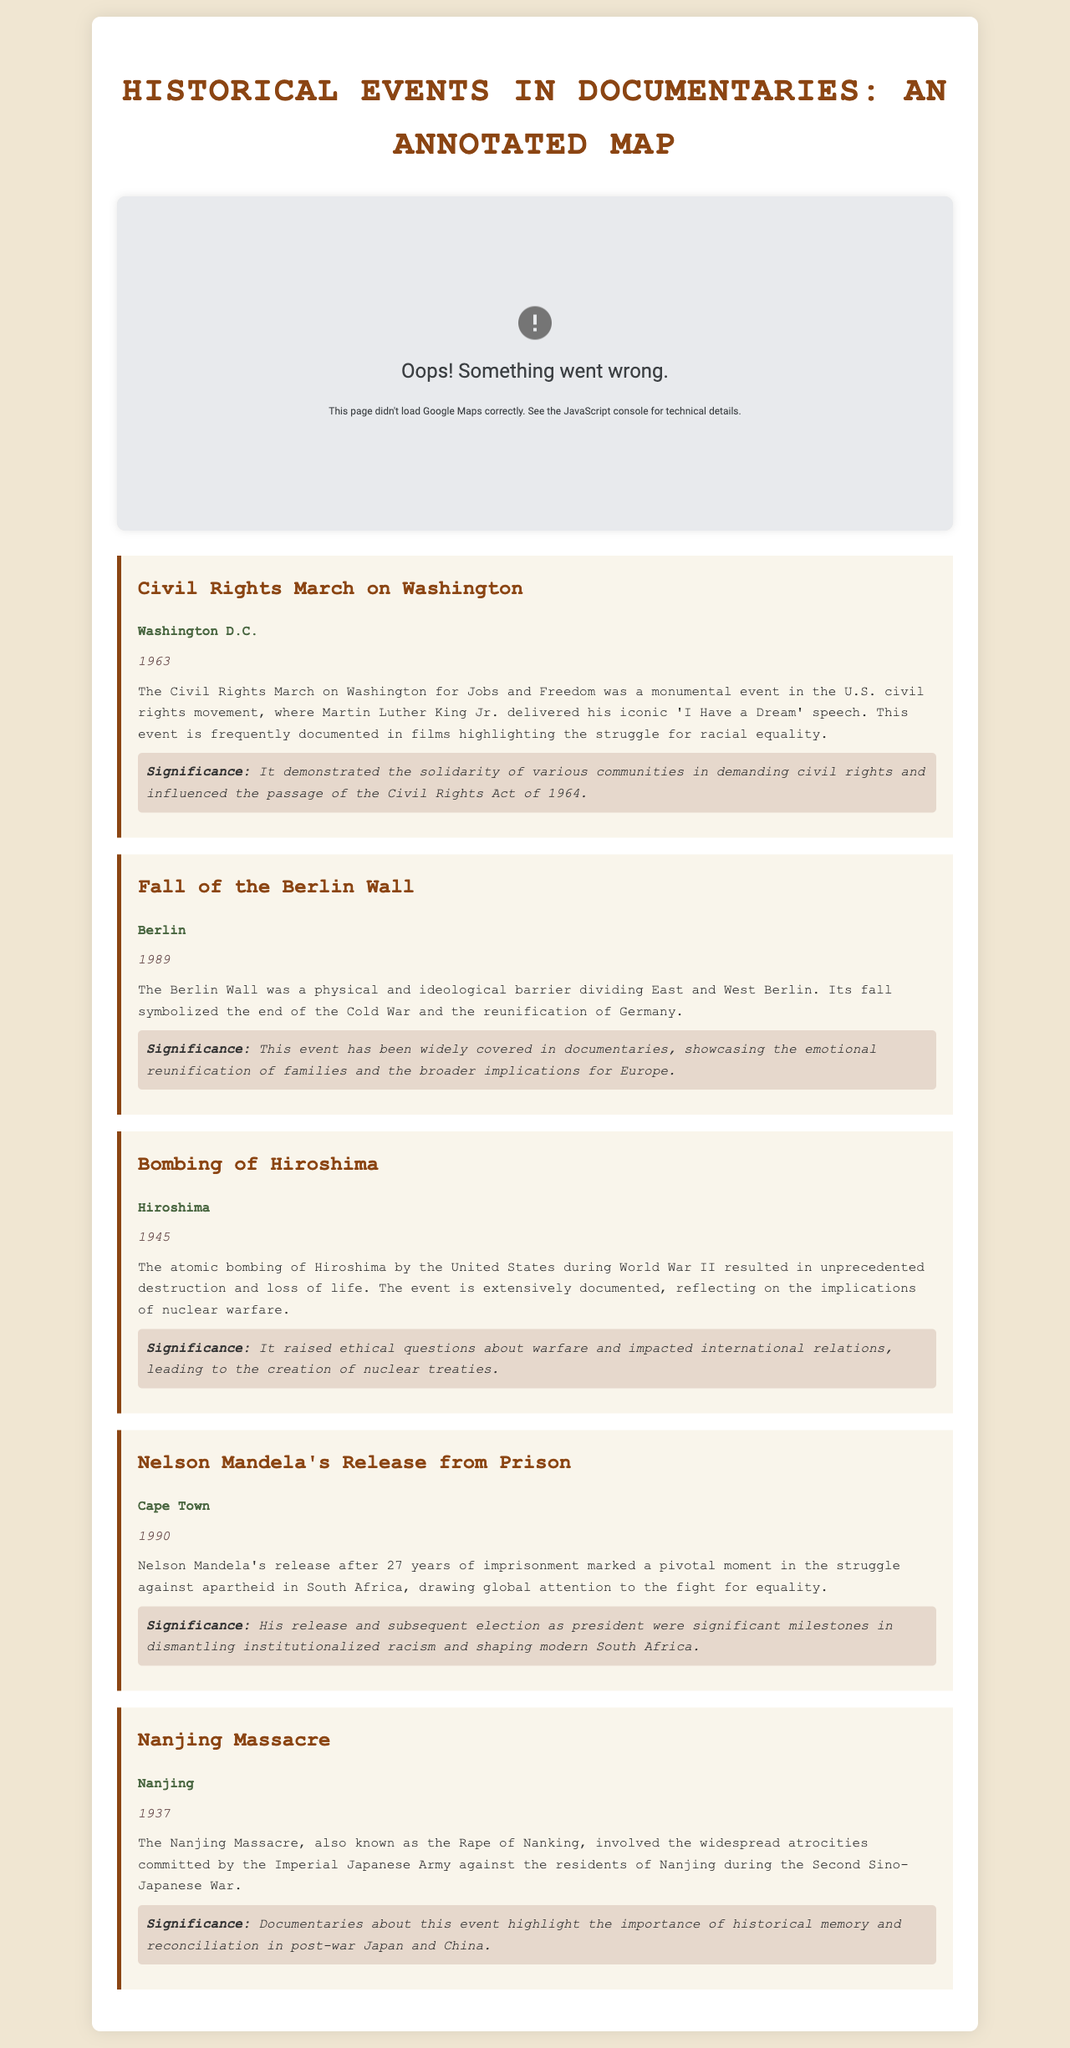What event took place in Washington D.C. in 1963? The event that took place in Washington D.C. in 1963 was the Civil Rights March on Washington.
Answer: Civil Rights March on Washington Which city is associated with the fall of the Berlin Wall? The city associated with the fall of the Berlin Wall is Berlin.
Answer: Berlin What year did Nelson Mandela get released from prison? Nelson Mandela was released from prison in the year 1990.
Answer: 1990 What is a significance of the Nanjing Massacre mentioned in the document? The significance of the Nanjing Massacre highlighted in the document is the importance of historical memory and reconciliation in post-war Japan and China.
Answer: Historical memory and reconciliation How many years was Nelson Mandela imprisoned before his release? Nelson Mandela was imprisoned for 27 years before his release in 1990.
Answer: 27 years 